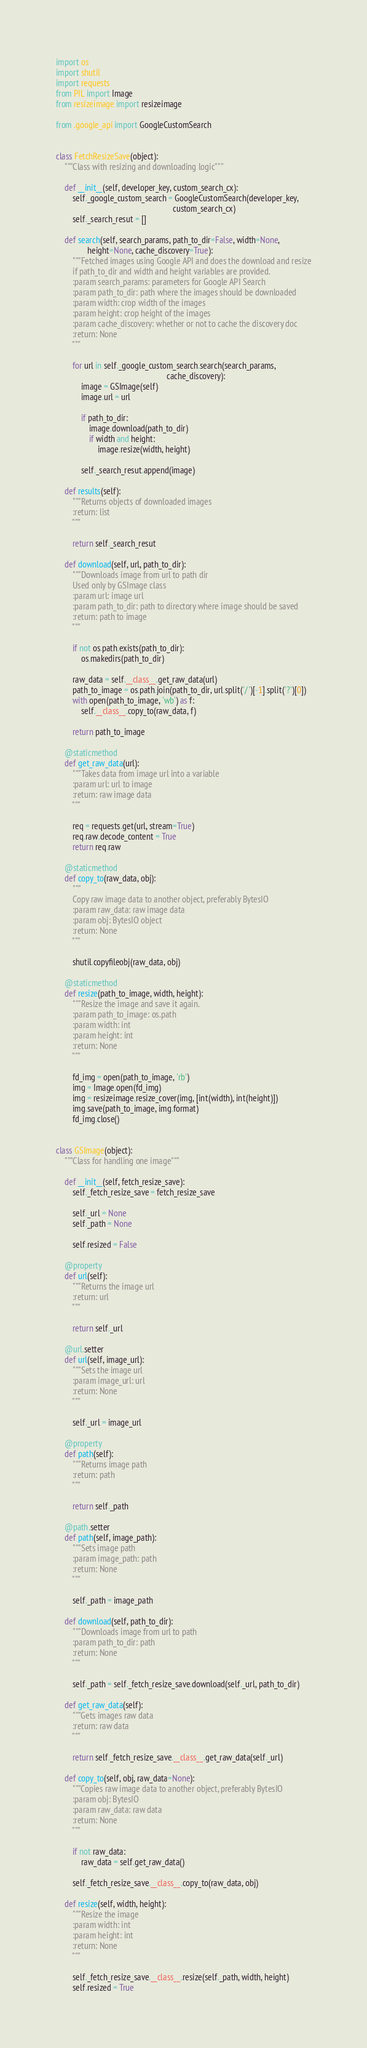<code> <loc_0><loc_0><loc_500><loc_500><_Python_>import os
import shutil
import requests
from PIL import Image
from resizeimage import resizeimage

from .google_api import GoogleCustomSearch


class FetchResizeSave(object):
    """Class with resizing and downloading logic"""

    def __init__(self, developer_key, custom_search_cx):
        self._google_custom_search = GoogleCustomSearch(developer_key,
                                                        custom_search_cx)
        self._search_resut = []

    def search(self, search_params, path_to_dir=False, width=None,
               height=None, cache_discovery=True):
        """Fetched images using Google API and does the download and resize
        if path_to_dir and width and height variables are provided.
        :param search_params: parameters for Google API Search
        :param path_to_dir: path where the images should be downloaded
        :param width: crop width of the images
        :param height: crop height of the images
        :param cache_discovery: whether or not to cache the discovery doc
        :return: None
        """

        for url in self._google_custom_search.search(search_params,
                                                     cache_discovery):
            image = GSImage(self)
            image.url = url

            if path_to_dir:
                image.download(path_to_dir)
                if width and height:
                    image.resize(width, height)

            self._search_resut.append(image)

    def results(self):
        """Returns objects of downloaded images
        :return: list
        """

        return self._search_resut

    def download(self, url, path_to_dir):
        """Downloads image from url to path dir
        Used only by GSImage class
        :param url: image url
        :param path_to_dir: path to directory where image should be saved
        :return: path to image
        """

        if not os.path.exists(path_to_dir):
            os.makedirs(path_to_dir)

        raw_data = self.__class__.get_raw_data(url)
        path_to_image = os.path.join(path_to_dir, url.split('/')[-1].split('?')[0])
        with open(path_to_image, 'wb') as f:
            self.__class__.copy_to(raw_data, f)

        return path_to_image

    @staticmethod
    def get_raw_data(url):
        """Takes data from image url into a variable
        :param url: url to image
        :return: raw image data
        """

        req = requests.get(url, stream=True)
        req.raw.decode_content = True
        return req.raw

    @staticmethod
    def copy_to(raw_data, obj):
        """
        Copy raw image data to another object, preferably BytesIO
        :param raw_data: raw image data
        :param obj: BytesIO object
        :return: None
        """

        shutil.copyfileobj(raw_data, obj)

    @staticmethod
    def resize(path_to_image, width, height):
        """Resize the image and save it again.
        :param path_to_image: os.path
        :param width: int
        :param height: int
        :return: None
        """

        fd_img = open(path_to_image, 'rb')
        img = Image.open(fd_img)
        img = resizeimage.resize_cover(img, [int(width), int(height)])
        img.save(path_to_image, img.format)
        fd_img.close()


class GSImage(object):
    """Class for handling one image"""

    def __init__(self, fetch_resize_save):
        self._fetch_resize_save = fetch_resize_save

        self._url = None
        self._path = None

        self.resized = False

    @property
    def url(self):
        """Returns the image url
        :return: url
        """

        return self._url

    @url.setter
    def url(self, image_url):
        """Sets the image url
        :param image_url: url
        :return: None
        """

        self._url = image_url

    @property
    def path(self):
        """Returns image path
        :return: path
        """

        return self._path

    @path.setter
    def path(self, image_path):
        """Sets image path
        :param image_path: path
        :return: None
        """

        self._path = image_path

    def download(self, path_to_dir):
        """Downloads image from url to path
        :param path_to_dir: path
        :return: None
        """

        self._path = self._fetch_resize_save.download(self._url, path_to_dir)

    def get_raw_data(self):
        """Gets images raw data
        :return: raw data
        """

        return self._fetch_resize_save.__class__.get_raw_data(self._url)

    def copy_to(self, obj, raw_data=None):
        """Copies raw image data to another object, preferably BytesIO
        :param obj: BytesIO
        :param raw_data: raw data
        :return: None
        """

        if not raw_data:
            raw_data = self.get_raw_data()

        self._fetch_resize_save.__class__.copy_to(raw_data, obj)

    def resize(self, width, height):
        """Resize the image
        :param width: int
        :param height: int
        :return: None
        """

        self._fetch_resize_save.__class__.resize(self._path, width, height)
        self.resized = True
</code> 